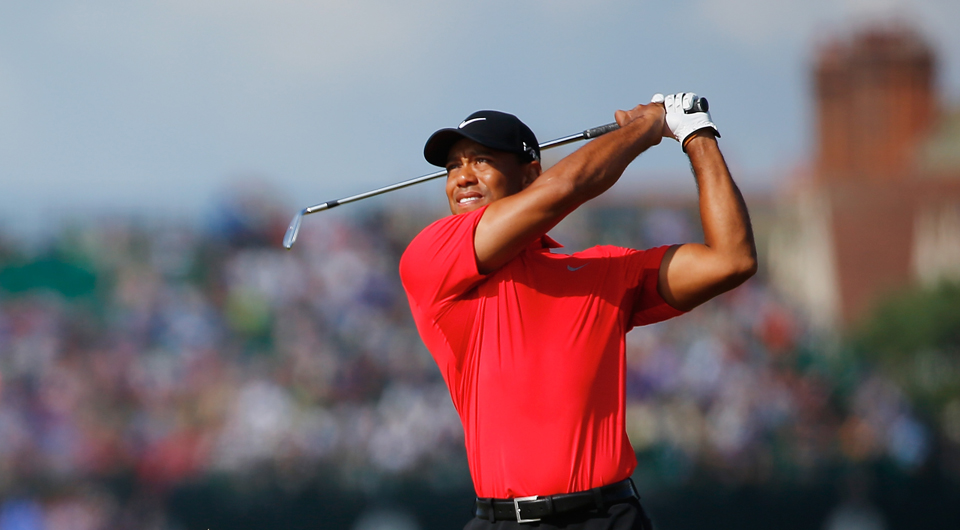Considering the crowd in the background, describe the likely atmosphere of the location. The atmosphere of the location is likely charged with excitement and anticipation. The presence of a large crowd, their faces lit with enthusiasm, implies a vibrant and dynamic environment. The energy is palpable as spectators eagerly follow the action, cheering and reacting to each shot. The natural surroundings of the golf course provide a picturesque backdrop, adding to the overall pleasant and exhilarating experience of being part of such a significant event. 